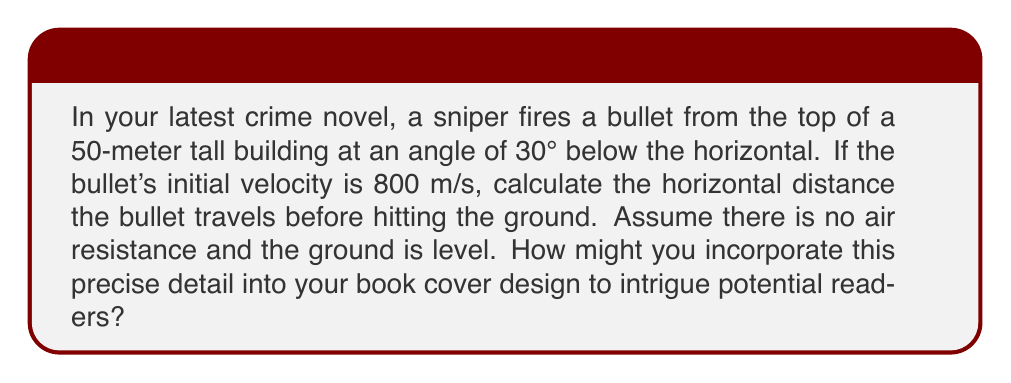Could you help me with this problem? Let's break this down step-by-step:

1) First, we need to identify the components of the bullet's velocity:
   
   Horizontal component: $v_x = v \cos\theta$
   Vertical component: $v_y = v \sin\theta$

   Where $v$ is the initial velocity and $\theta$ is the angle below the horizontal.

2) Calculate these components:
   $v_x = 800 \cos(30°) = 800 \cdot \frac{\sqrt{3}}{2} \approx 692.82$ m/s
   $v_y = -800 \sin(30°) = -800 \cdot \frac{1}{2} = -400$ m/s (negative because it's going down)

3) Now, we can use the equations of motion:
   
   Horizontal motion: $x = v_x t$
   Vertical motion: $y = h + v_y t - \frac{1}{2}gt^2$

   Where $h$ is the initial height, $g$ is the acceleration due to gravity (9.8 m/s²), and $t$ is time.

4) We want to find when the bullet hits the ground, so $y = 0$:

   $0 = 50 - 400t - 4.9t^2$

5) Solve this quadratic equation:
   
   $4.9t^2 + 400t - 50 = 0$
   
   Using the quadratic formula: $t = \frac{-b \pm \sqrt{b^2 - 4ac}}{2a}$

   $t = \frac{-400 \pm \sqrt{400^2 - 4(4.9)(-50)}}{2(4.9)} \approx 3.06$ s (we take the positive root)

6) Now that we know the time, we can calculate the horizontal distance:

   $x = v_x t = 692.82 \cdot 3.06 \approx 2120.03$ meters
Answer: The bullet travels approximately 2120 meters horizontally before hitting the ground. 